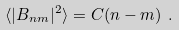<formula> <loc_0><loc_0><loc_500><loc_500>\langle | B _ { n m } | ^ { 2 } \rangle = C ( n - m ) \ .</formula> 